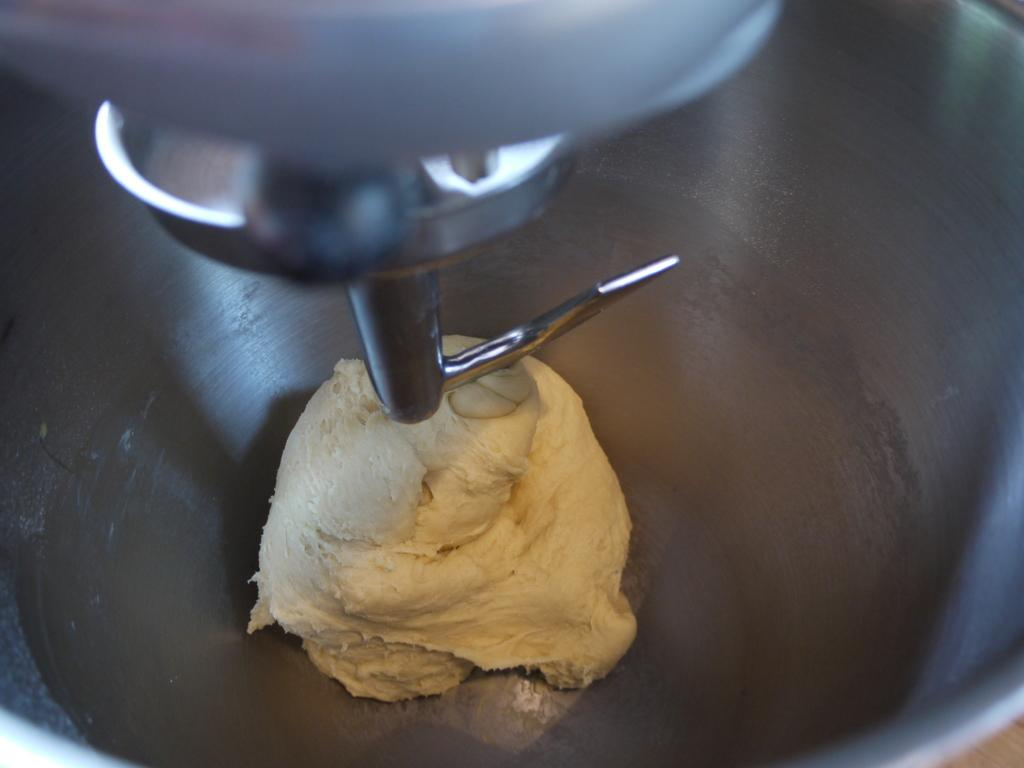What is the main subject of the image? The main subject of the image is dough. Where is the dough located in the image? The dough is in a machine. What is the tendency of the dough to fly in the image? There is no indication of the dough flying or having any tendency to fly in the image. 